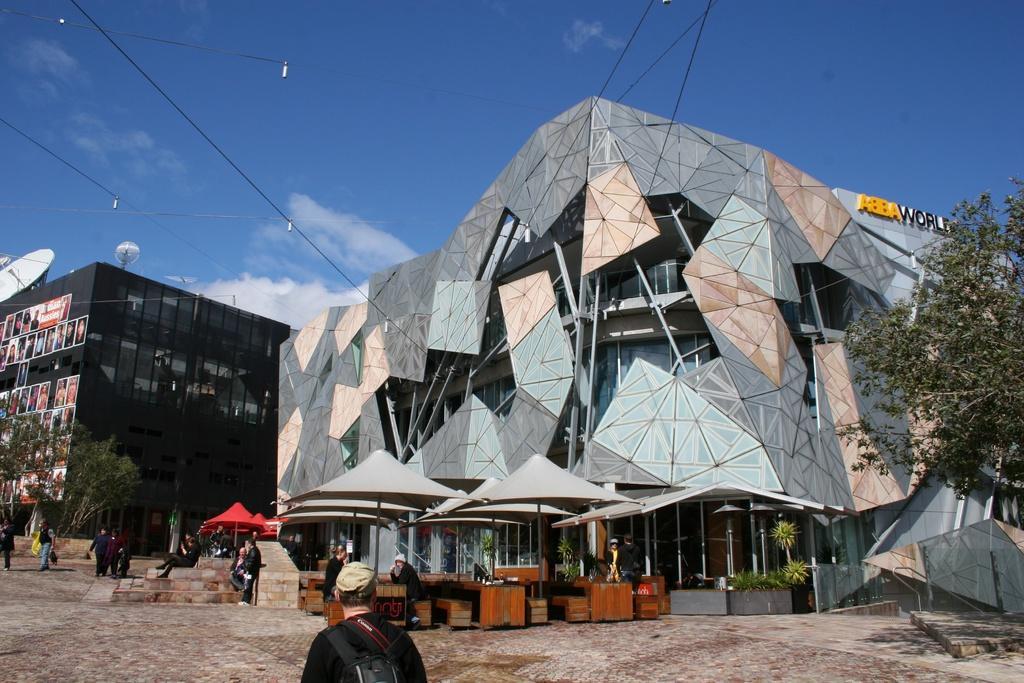Please provide a concise description of this image. In this picture there is a 3D design building in the middle of the photograph. In the front bottom side there is a open restaurant with some tables and chairs. Beside there is a black glass building. On the front bottom side there is a man wearing black jacket and backpack is standing and looking to the building. 